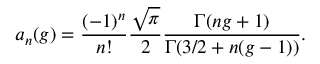<formula> <loc_0><loc_0><loc_500><loc_500>a _ { n } ( g ) = \frac { ( - 1 ) ^ { n } } { n ! } \frac { \sqrt { \pi } } { 2 } \frac { \Gamma ( n g + 1 ) } { \Gamma ( 3 / 2 + n ( g - 1 ) ) } .</formula> 